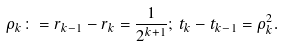<formula> <loc_0><loc_0><loc_500><loc_500>\rho _ { k } \colon = r _ { k - 1 } - r _ { k } = \frac { 1 } { 2 ^ { k + 1 } } ; \, t _ { k } - t _ { k - 1 } = \rho ^ { 2 } _ { k } .</formula> 